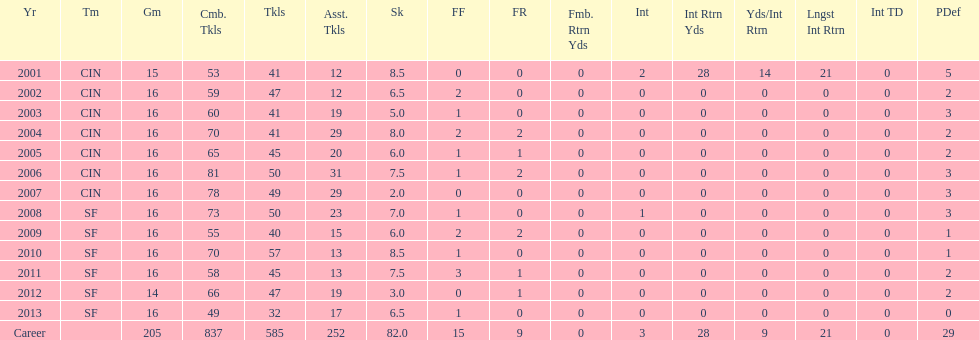What is the only season he has fewer than three sacks? 2007. 